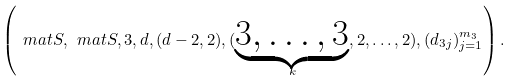<formula> <loc_0><loc_0><loc_500><loc_500>\left ( \ m a t S , \ m a t S , 3 , d , ( d - 2 , 2 ) , ( \underbrace { 3 , \dots , 3 } _ { k } , 2 , \dots , 2 ) , ( d _ { 3 j } ) _ { j = 1 } ^ { m _ { 3 } } \right ) .</formula> 